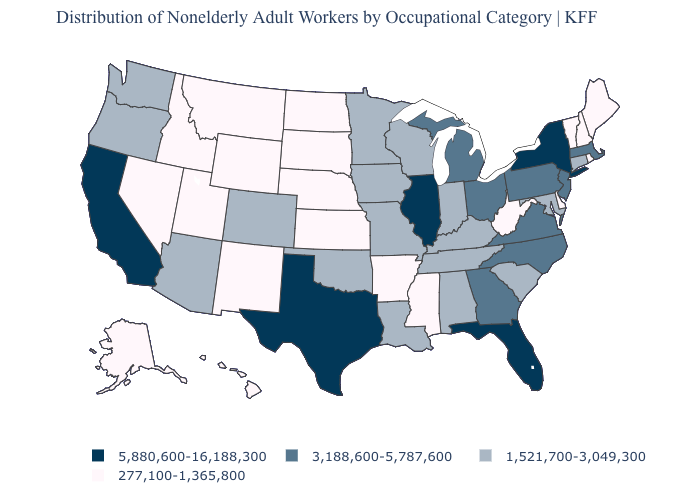Does Iowa have the same value as North Dakota?
Write a very short answer. No. What is the value of New Mexico?
Answer briefly. 277,100-1,365,800. How many symbols are there in the legend?
Short answer required. 4. Name the states that have a value in the range 3,188,600-5,787,600?
Write a very short answer. Georgia, Massachusetts, Michigan, New Jersey, North Carolina, Ohio, Pennsylvania, Virginia. What is the value of Delaware?
Quick response, please. 277,100-1,365,800. What is the highest value in states that border Wisconsin?
Answer briefly. 5,880,600-16,188,300. Among the states that border Pennsylvania , does Ohio have the lowest value?
Be succinct. No. What is the lowest value in the USA?
Be succinct. 277,100-1,365,800. Name the states that have a value in the range 3,188,600-5,787,600?
Quick response, please. Georgia, Massachusetts, Michigan, New Jersey, North Carolina, Ohio, Pennsylvania, Virginia. What is the highest value in the USA?
Write a very short answer. 5,880,600-16,188,300. Name the states that have a value in the range 5,880,600-16,188,300?
Keep it brief. California, Florida, Illinois, New York, Texas. Does Mississippi have a lower value than Rhode Island?
Concise answer only. No. What is the value of California?
Be succinct. 5,880,600-16,188,300. Name the states that have a value in the range 1,521,700-3,049,300?
Quick response, please. Alabama, Arizona, Colorado, Connecticut, Indiana, Iowa, Kentucky, Louisiana, Maryland, Minnesota, Missouri, Oklahoma, Oregon, South Carolina, Tennessee, Washington, Wisconsin. Is the legend a continuous bar?
Be succinct. No. 